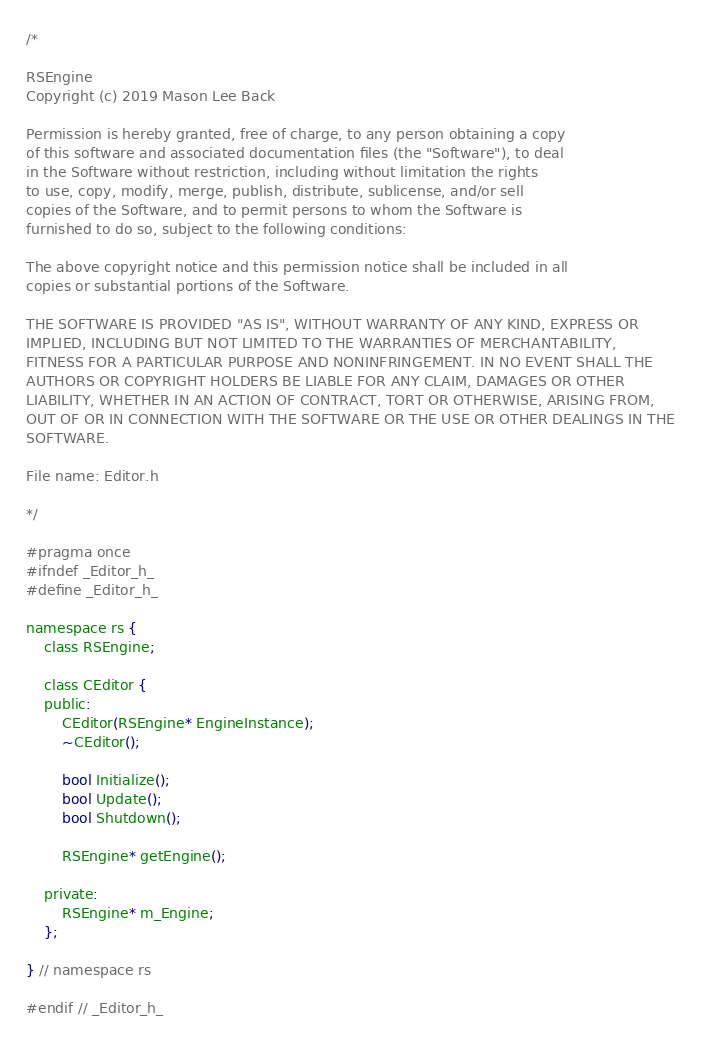<code> <loc_0><loc_0><loc_500><loc_500><_C_>/*

RSEngine
Copyright (c) 2019 Mason Lee Back

Permission is hereby granted, free of charge, to any person obtaining a copy
of this software and associated documentation files (the "Software"), to deal
in the Software without restriction, including without limitation the rights
to use, copy, modify, merge, publish, distribute, sublicense, and/or sell
copies of the Software, and to permit persons to whom the Software is
furnished to do so, subject to the following conditions:

The above copyright notice and this permission notice shall be included in all
copies or substantial portions of the Software.

THE SOFTWARE IS PROVIDED "AS IS", WITHOUT WARRANTY OF ANY KIND, EXPRESS OR
IMPLIED, INCLUDING BUT NOT LIMITED TO THE WARRANTIES OF MERCHANTABILITY,
FITNESS FOR A PARTICULAR PURPOSE AND NONINFRINGEMENT. IN NO EVENT SHALL THE
AUTHORS OR COPYRIGHT HOLDERS BE LIABLE FOR ANY CLAIM, DAMAGES OR OTHER
LIABILITY, WHETHER IN AN ACTION OF CONTRACT, TORT OR OTHERWISE, ARISING FROM,
OUT OF OR IN CONNECTION WITH THE SOFTWARE OR THE USE OR OTHER DEALINGS IN THE
SOFTWARE.

File name: Editor.h

*/

#pragma once
#ifndef _Editor_h_
#define _Editor_h_

namespace rs {
    class RSEngine;

    class CEditor {
    public:
        CEditor(RSEngine* EngineInstance);
        ~CEditor();

        bool Initialize();
        bool Update();
        bool Shutdown();

        RSEngine* getEngine();

    private:
        RSEngine* m_Engine;
    };

} // namespace rs

#endif // _Editor_h_
</code> 